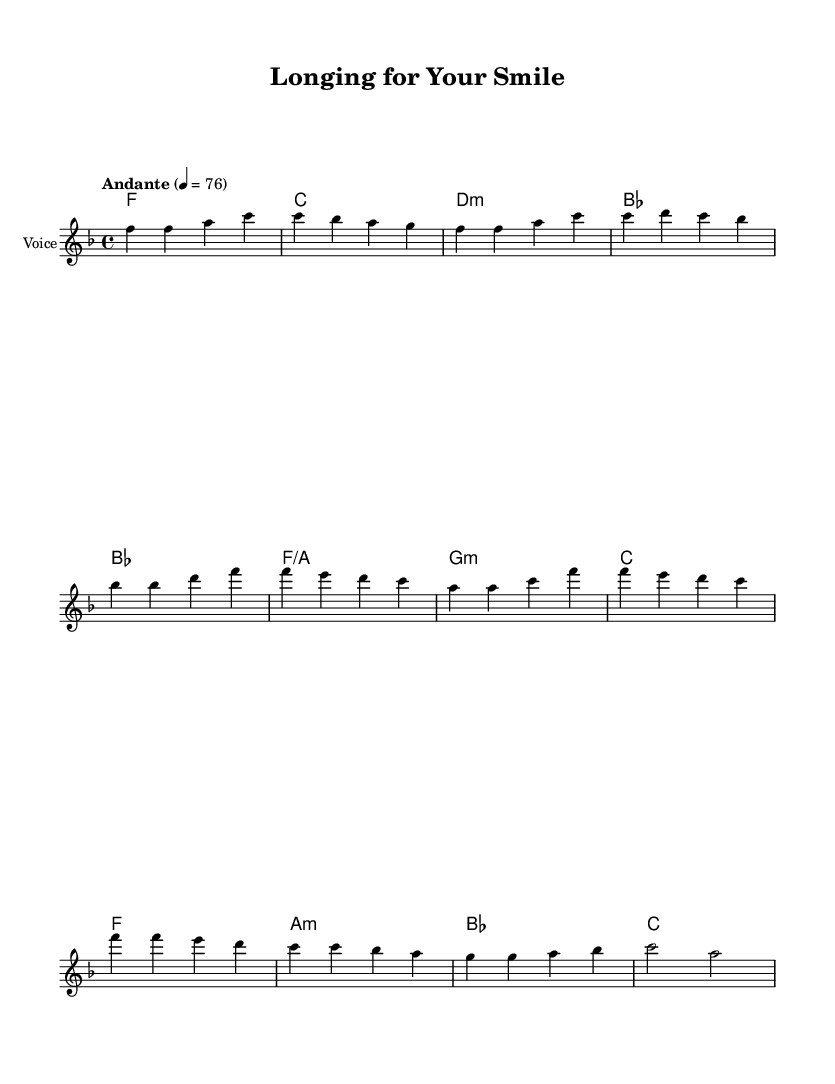What is the key signature of this music? The key signature is F major, indicated by one flat (B). This can be identified by examining the key signature symbol at the beginning of the staff.
Answer: F major What is the time signature of the piece? The time signature is 4/4, as shown at the beginning of the score. This means there are four beats in each measure, with each beat being a quarter note.
Answer: 4/4 What is the tempo marking for this music? The tempo marking is "Andante," which suggests a moderately slow tempo. This can be determined from the tempo indication provided above the music notation.
Answer: Andante How many measures are in the melody? The melody contains 8 measures, which can be counted by identifying the vertical bar lines that separate the measures within the score.
Answer: 8 measures What is the last chord in the chorus section? The last chord in the chorus section is C major. By looking at the chord progression in the harmonies, we see that it ends with the C chord.
Answer: C major What is the range of the melody? The range of the melody spans from F to D, which can be determined by identifying the lowest note (F) in the first measure and the highest note (D) in the pre-chorus.
Answer: F to D What musical elements in this piece suggest it is a K-Pop ballad? The piece contains emotional lyrics and harmonic progressions typical of K-Pop ballads, characterized by heartfelt melodies and relational themes — evidenced in the expressive lines of the chorus and verse.
Answer: Emotional lyrics, expressive melodies 